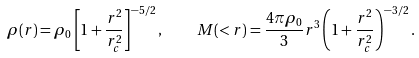Convert formula to latex. <formula><loc_0><loc_0><loc_500><loc_500>\rho ( r ) = \rho _ { 0 } \left [ 1 + \frac { r ^ { 2 } } { r ^ { 2 } _ { c } } \right ] ^ { - 5 / 2 } , \quad M ( < r ) = \frac { 4 \pi \rho _ { 0 } } { 3 } r ^ { 3 } \left ( 1 + \frac { r ^ { 2 } } { r _ { c } ^ { 2 } } \right ) ^ { - 3 / 2 } .</formula> 